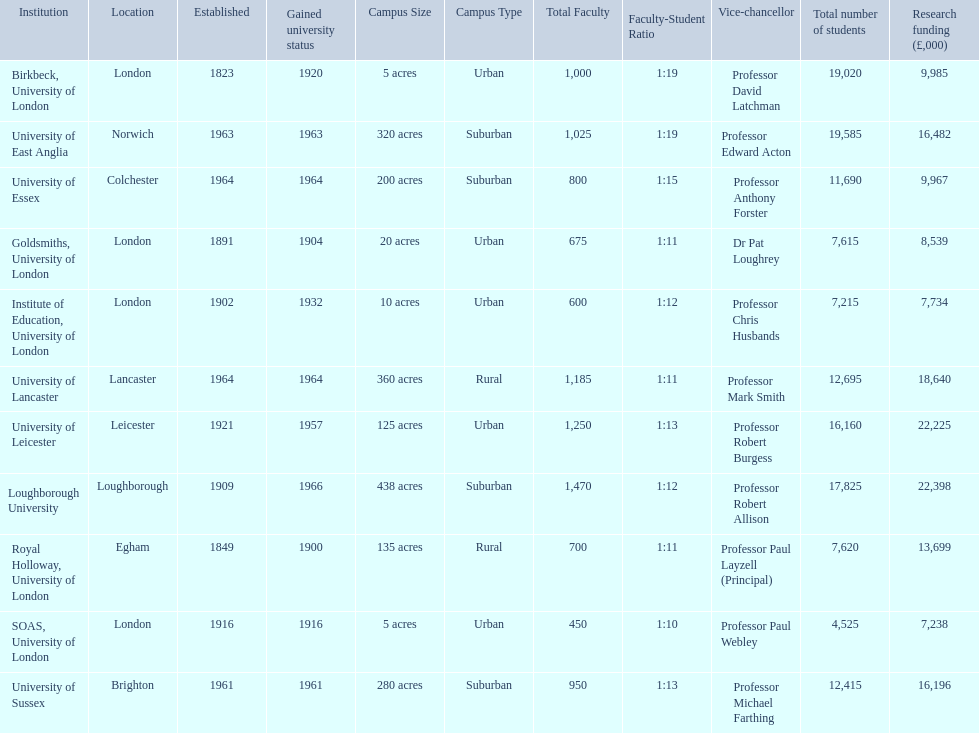What is the most recent institution to gain university status? Loughborough University. 